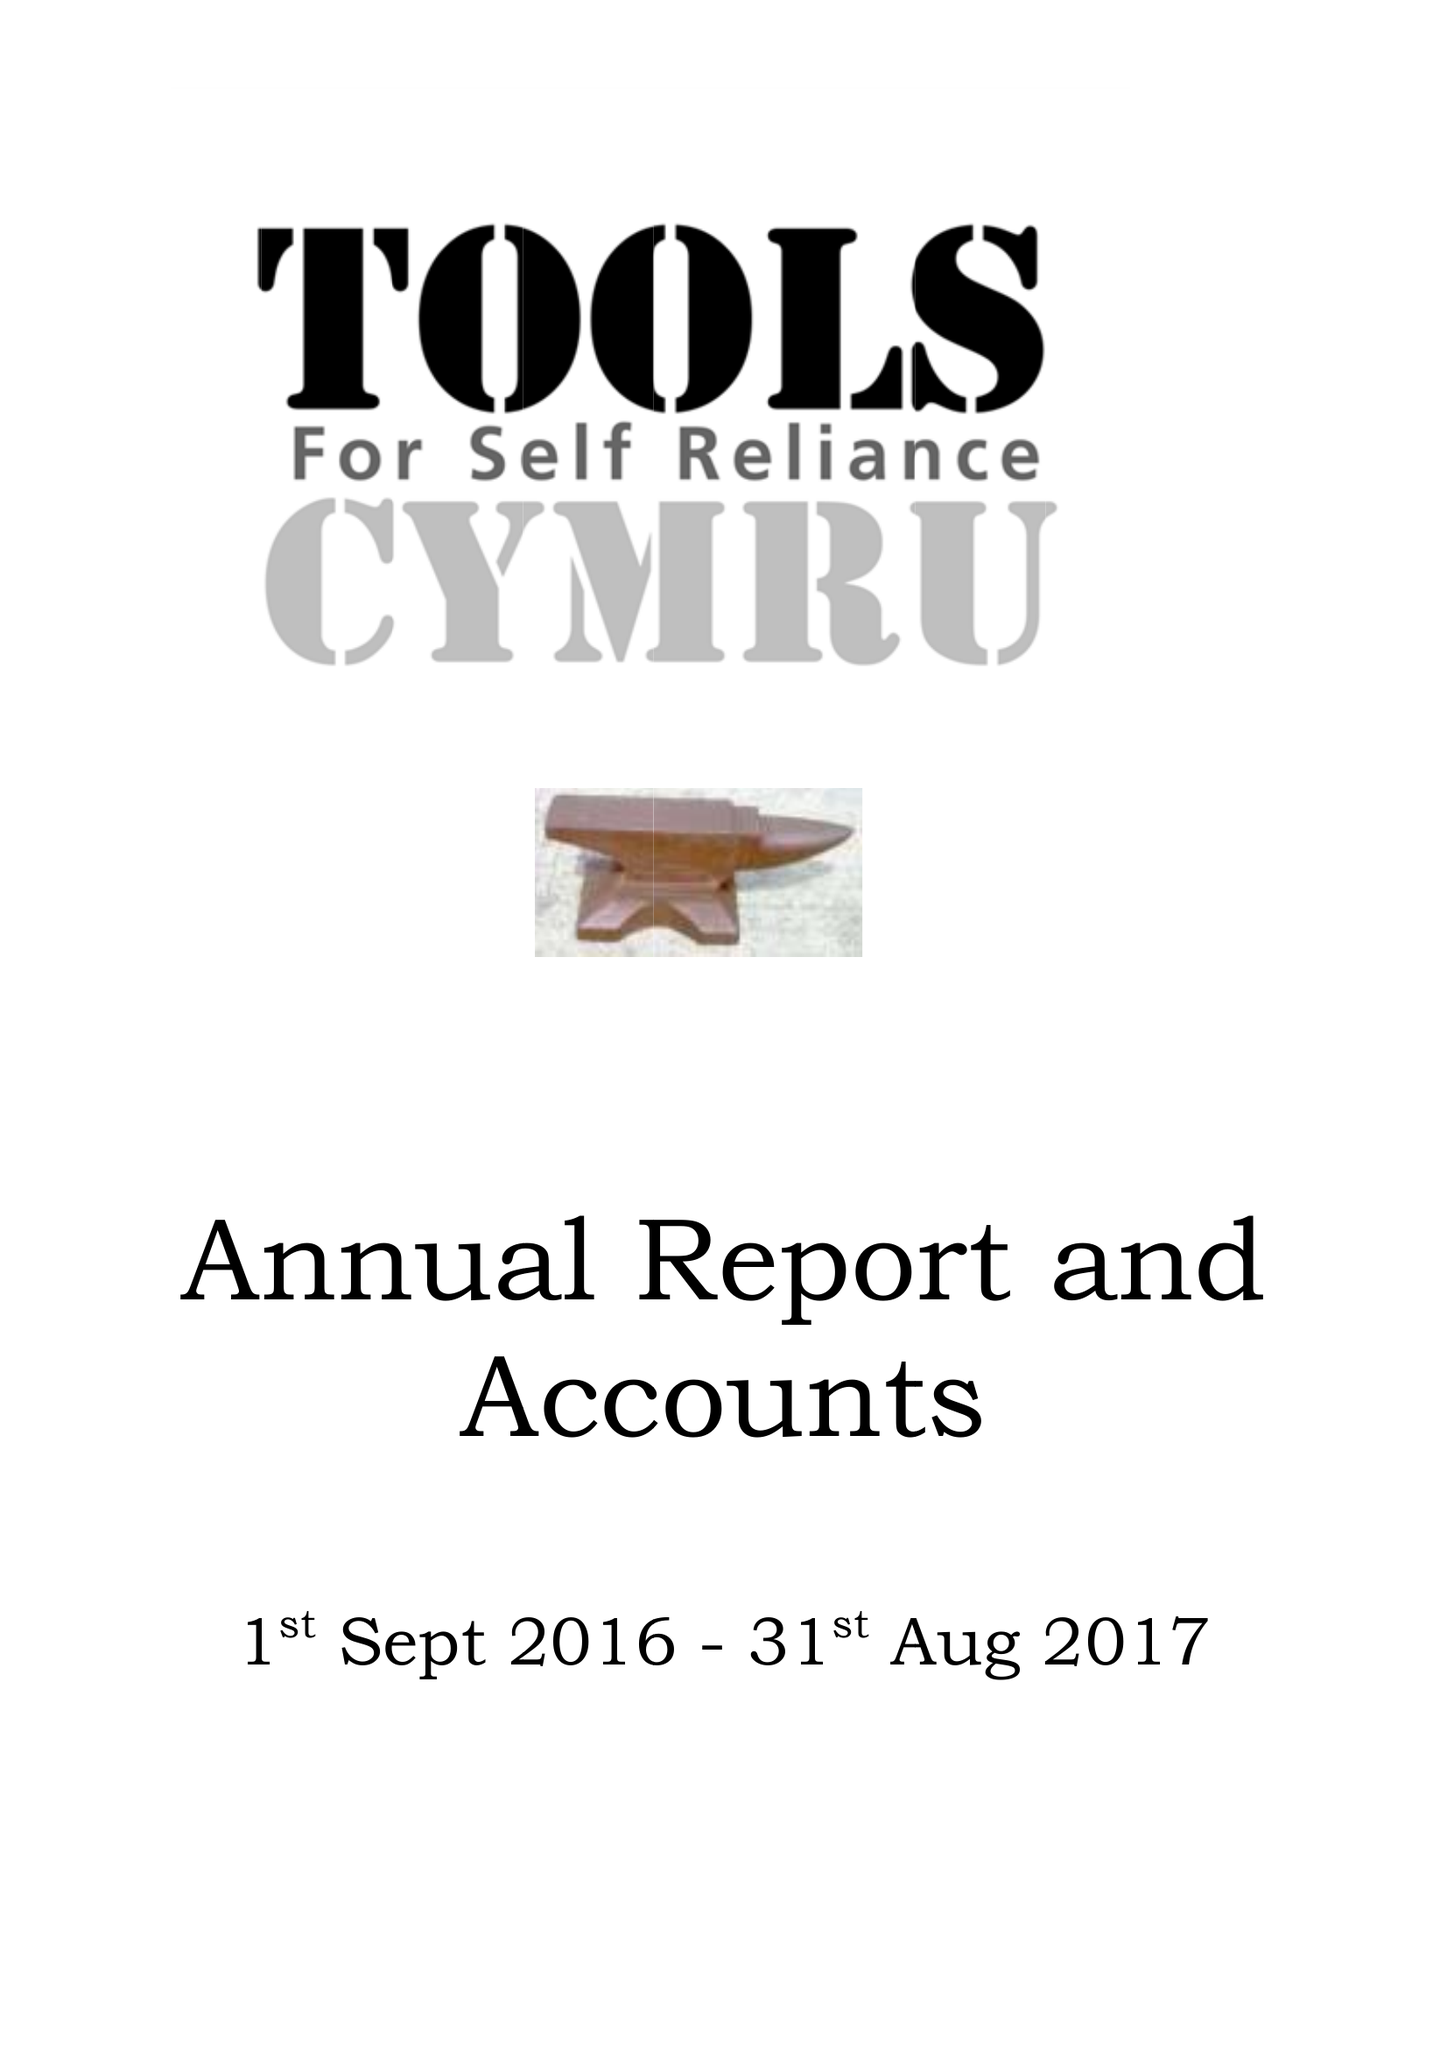What is the value for the report_date?
Answer the question using a single word or phrase. 2017-08-31 